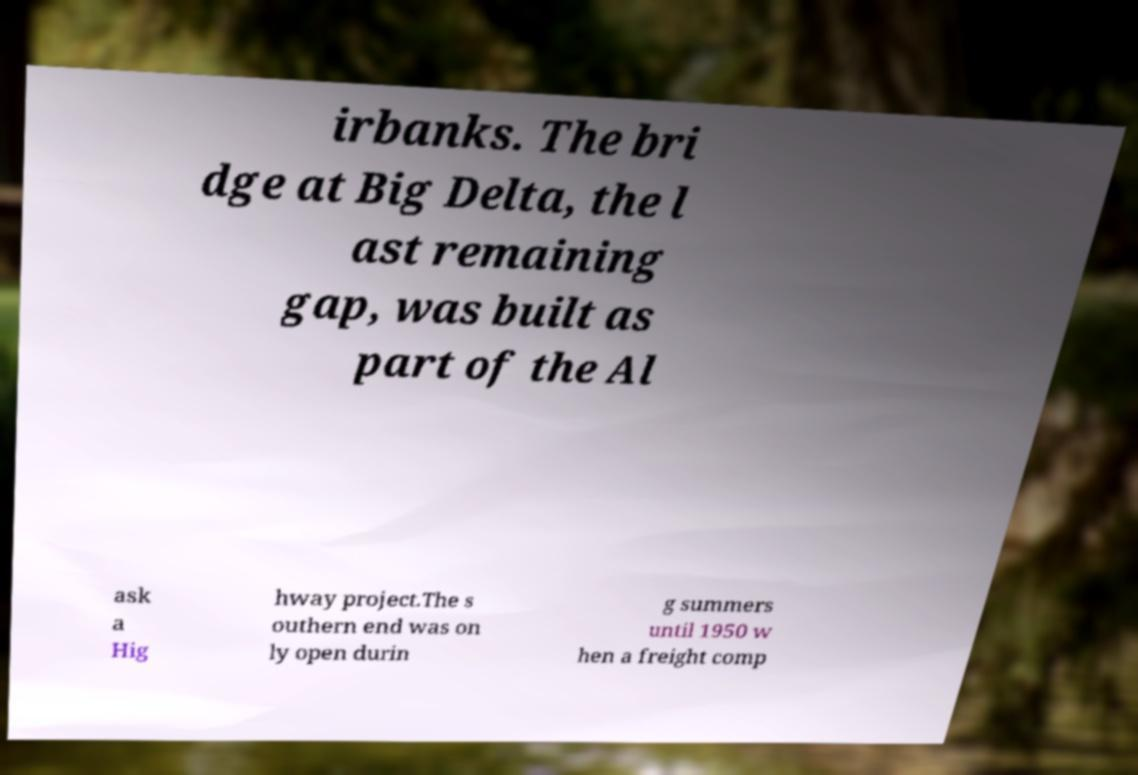Please read and relay the text visible in this image. What does it say? irbanks. The bri dge at Big Delta, the l ast remaining gap, was built as part of the Al ask a Hig hway project.The s outhern end was on ly open durin g summers until 1950 w hen a freight comp 